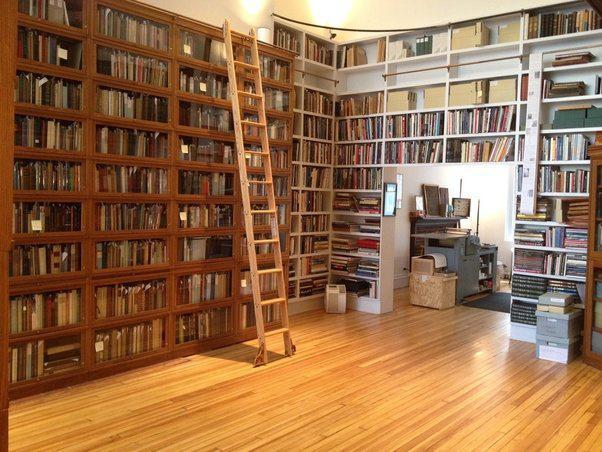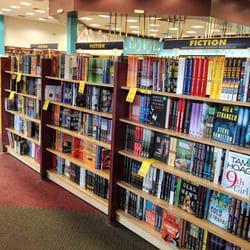The first image is the image on the left, the second image is the image on the right. Evaluate the accuracy of this statement regarding the images: "One image shows the spines of books lined upright in a row, and the other image shows books stacked mostly upright on shelves, with some books stacked on their sides.". Is it true? Answer yes or no. No. The first image is the image on the left, the second image is the image on the right. Given the left and right images, does the statement "There are at least 13 books that are red, blue or white sitting on a single unseen shelve." hold true? Answer yes or no. No. 